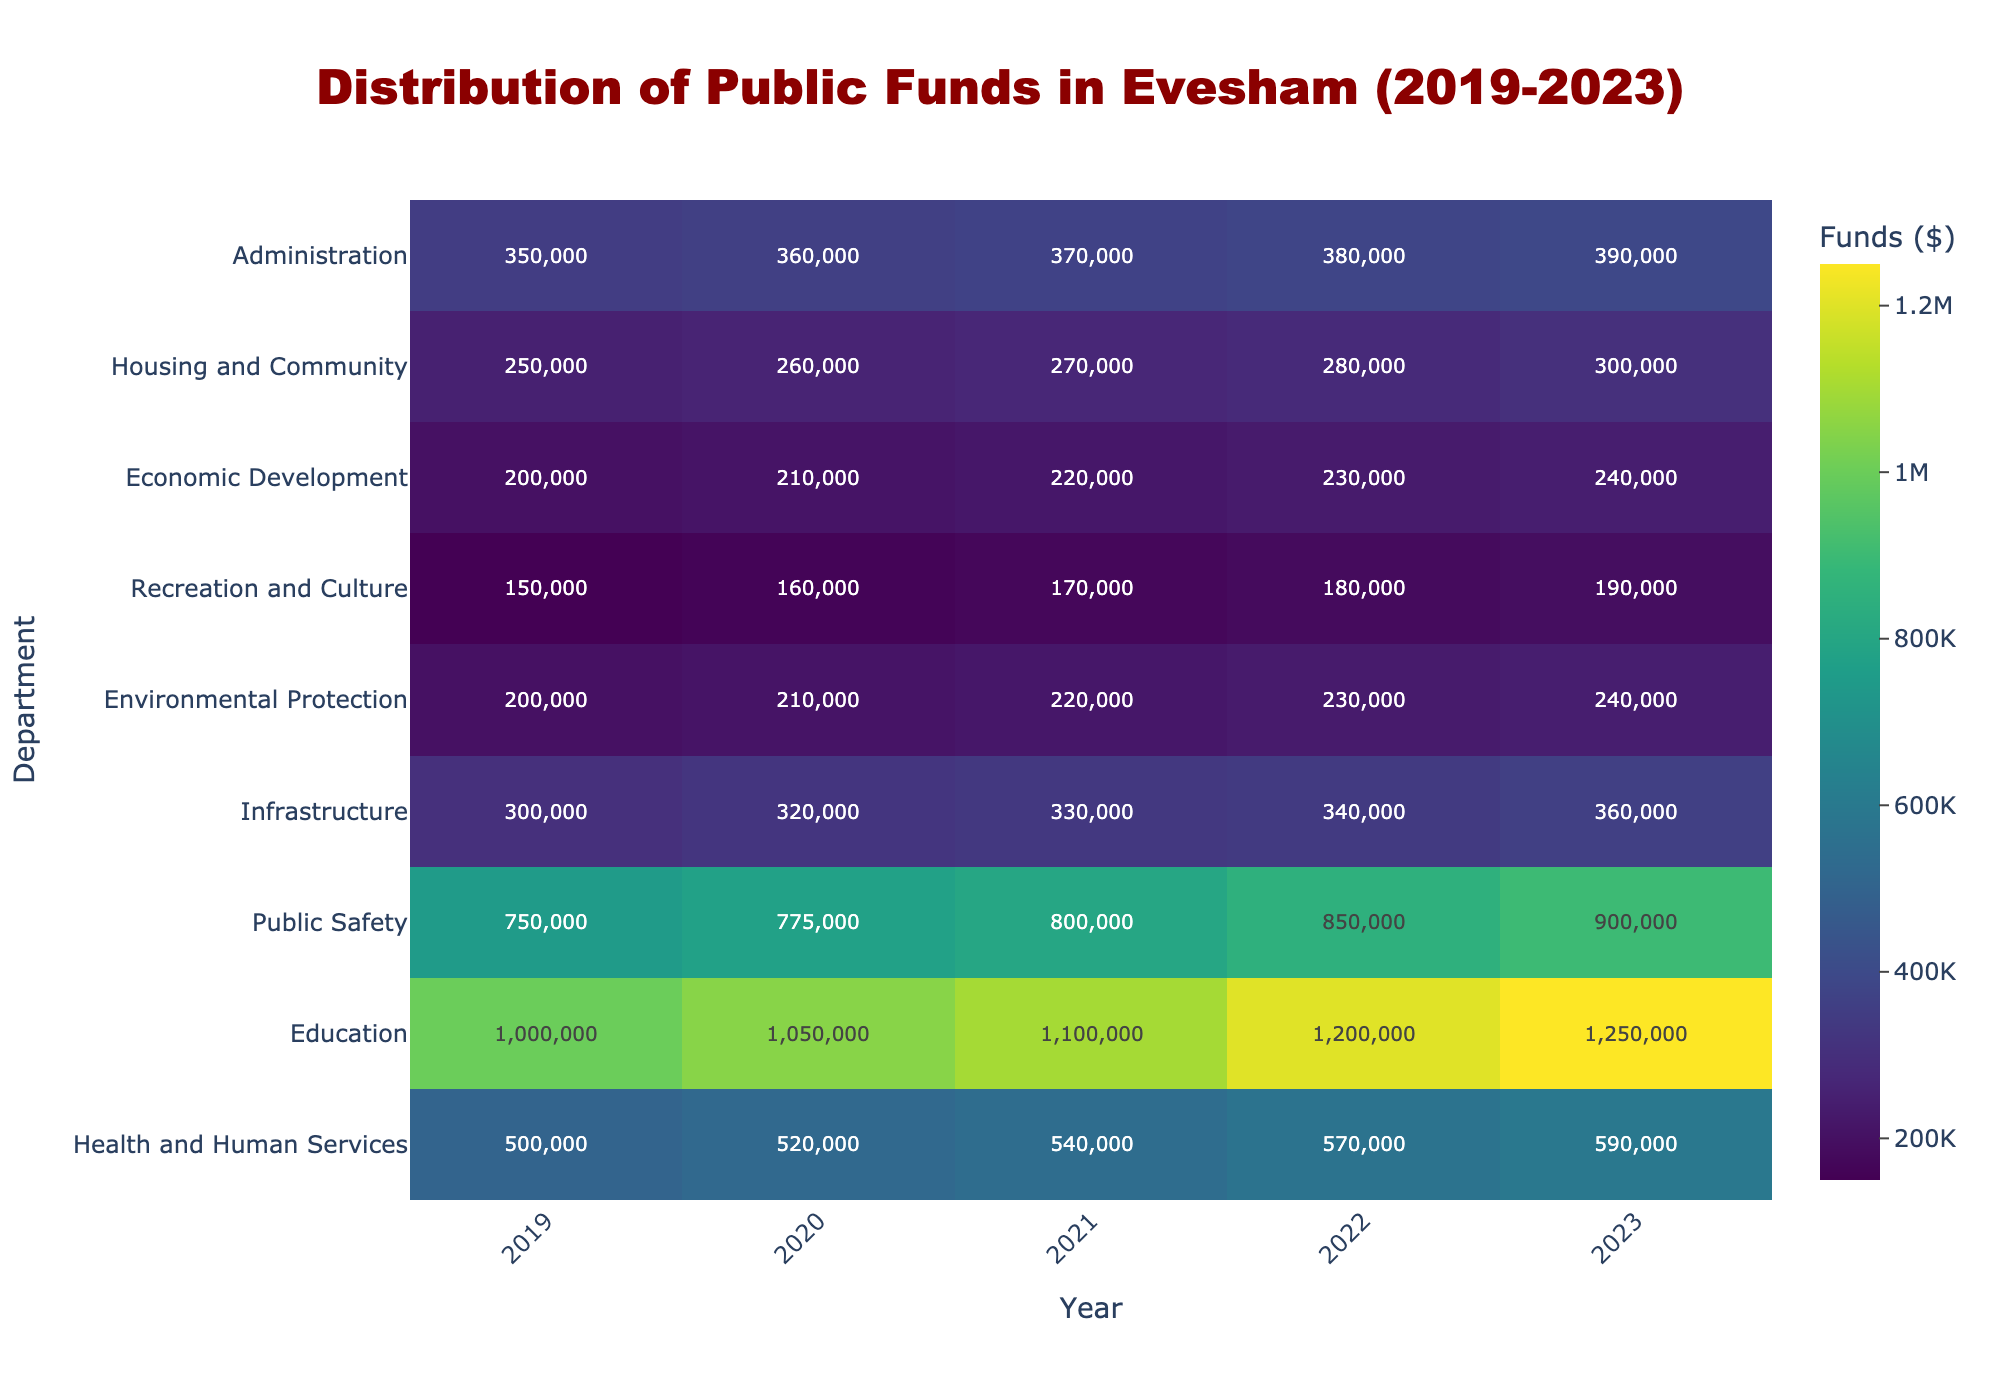What's the title of the heatmap? The title is usually located at the top of the heatmap. In this case, it reads "Distribution of Public Funds in Evesham (2019-2023)".
Answer: Distribution of Public Funds in Evesham (2019-2023) Which department received the highest funding in 2023? Look for the highest value in the 2023 column, which corresponds to the department "Education" with $1,250,000.
Answer: Education How has the funding for Public Safety changed from 2019 to 2023? Examine the values for the Public Safety department from 2019 to 2023. It increased from $750,000 in 2019 to $900,000 in 2023.
Answer: Increased by $150,000 Which department had the lowest funding in 2022? Find the lowest value in the 2022 column, which is "Recreation and Culture" with $180,000.
Answer: Recreation and Culture What is the total amount of public funds allocated to the Administration department over the five years? Sum the values for the Administration department: $350,000 + $360,000 + $370,000 + $380,000 + $390,000 = $1,850,000.
Answer: $1,850,000 Compare the funding trends for Health and Human Services and Economic Development from 2019 to 2023. Both departments show a consistent increase. Health and Human Services went from $500,000 to $590,000 and Economic Development from $200,000 to $240,000.
Answer: Both increased, but Health and Human Services increased more What year saw the largest increase in funding for the Education department? Compare the year-over-year changes for the Education department. The largest increase was from 2020 to 2021, increasing by $50,000 ($1,100,000 - $1,050,000).
Answer: 2021 Which department had a consistent increase of $10,000 every year? Identify the department with a $10,000 yearly increment. Both "Environmental Protection" and "Economic Development" increased by $10,000 each year from 2019 to 2023.
Answer: Environmental Protection and Economic Development Rank the departments based on their 2021 funding levels. Order the departments by their 2021 funding amounts: Education ($1,100,000), Public Safety ($800,000), Health and Human Services ($540,000), Administration ($370,000), Infrastructure ($330,000), Housing and Community ($270,000), Economic Development ($220,000), Environmental Protection ($220,000), Recreation and Culture ($170,000).
Answer: Education > Public Safety > Health and Human Services > Administration > Infrastructure > Housing and Community > Economic Development = Environmental Protection > Recreation and Culture 